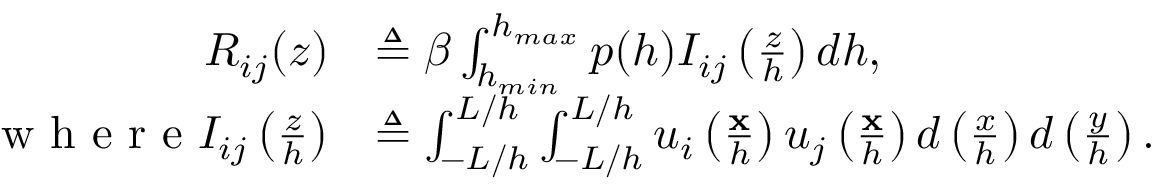Convert formula to latex. <formula><loc_0><loc_0><loc_500><loc_500>\begin{array} { r l } { R _ { i j } ( z ) } & { \triangle q \beta \int _ { h _ { \min } } ^ { h _ { \max } } p ( h ) I _ { i j } \left ( \frac { z } { h } \right ) d h , } \\ { w h e r e I _ { i j } \left ( \frac { z } { h } \right ) } & { \triangle q \int _ { - L / h } ^ { L / h } \int _ { - L / h } ^ { L / h } u _ { i } \left ( \frac { x } { h } \right ) u _ { j } \left ( \frac { x } { h } \right ) d \left ( \frac { x } { h } \right ) d \left ( \frac { y } { h } \right ) . } \end{array}</formula> 